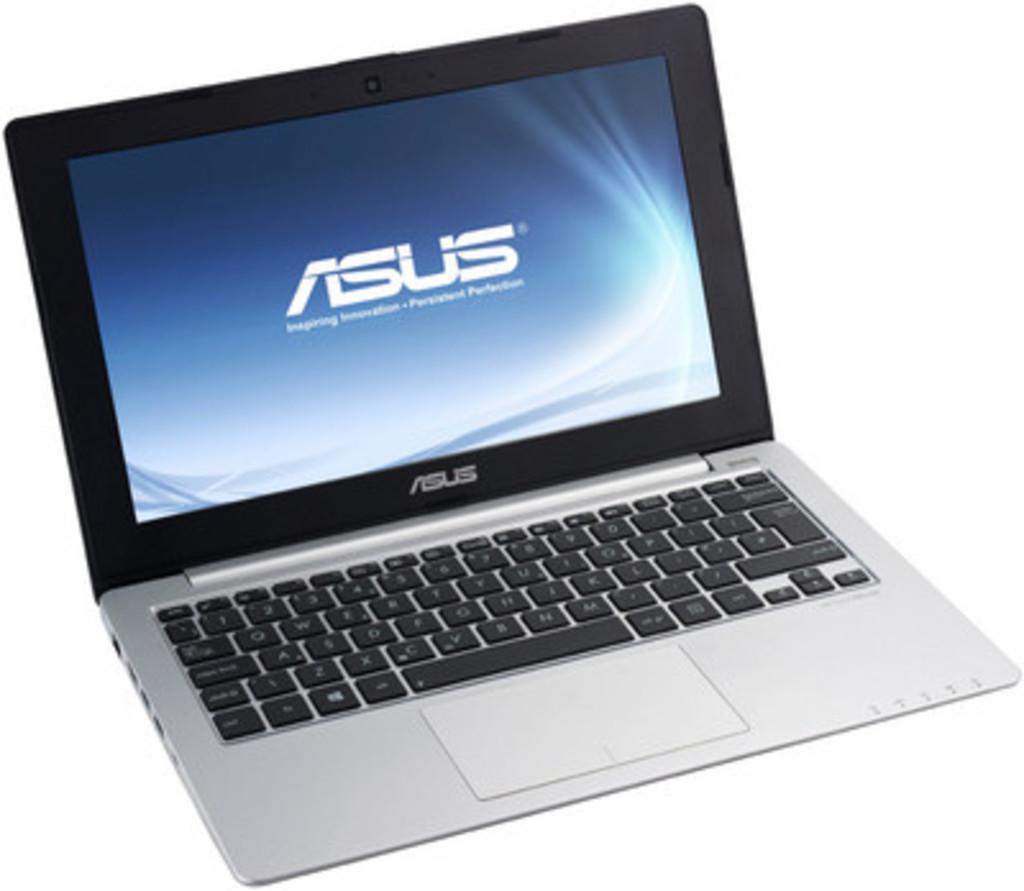What laptop is that?
Make the answer very short. Asus. 